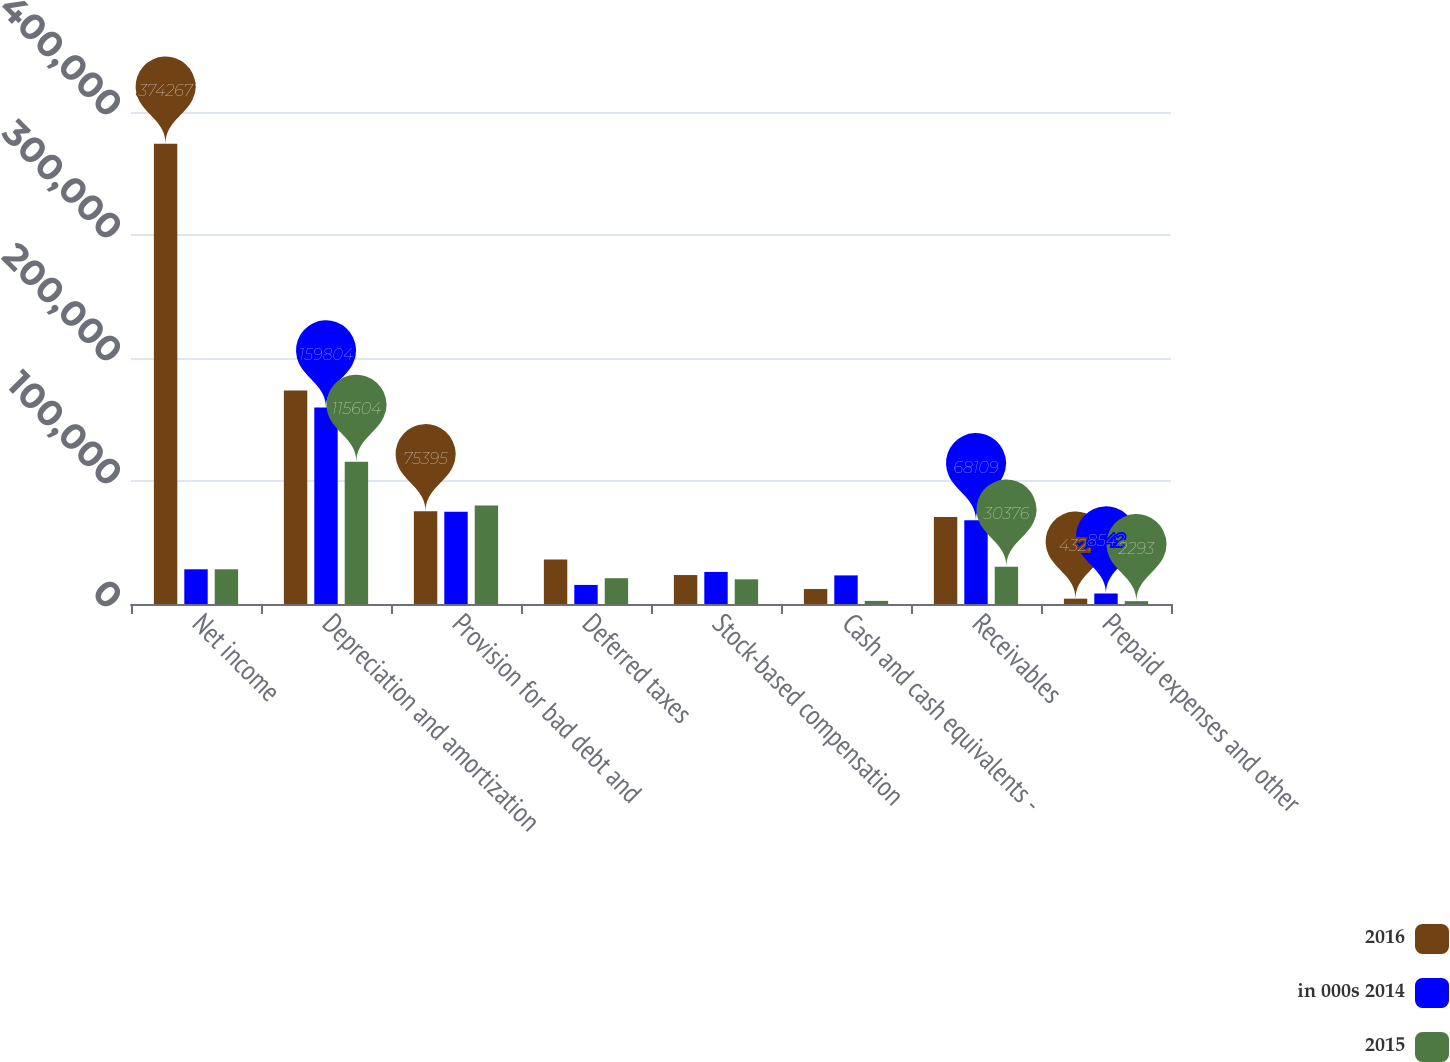Convert chart to OTSL. <chart><loc_0><loc_0><loc_500><loc_500><stacked_bar_chart><ecel><fcel>Net income<fcel>Depreciation and amortization<fcel>Provision for bad debt and<fcel>Deferred taxes<fcel>Stock-based compensation<fcel>Cash and cash equivalents -<fcel>Receivables<fcel>Prepaid expenses and other<nl><fcel>2016<fcel>374267<fcel>173598<fcel>75395<fcel>36276<fcel>23540<fcel>12159<fcel>70721<fcel>4321<nl><fcel>in 000s 2014<fcel>28222<fcel>159804<fcel>74993<fcel>15502<fcel>26068<fcel>23252<fcel>68109<fcel>8542<nl><fcel>2015<fcel>28222<fcel>115604<fcel>80007<fcel>20958<fcel>20058<fcel>2522<fcel>30376<fcel>2293<nl></chart> 